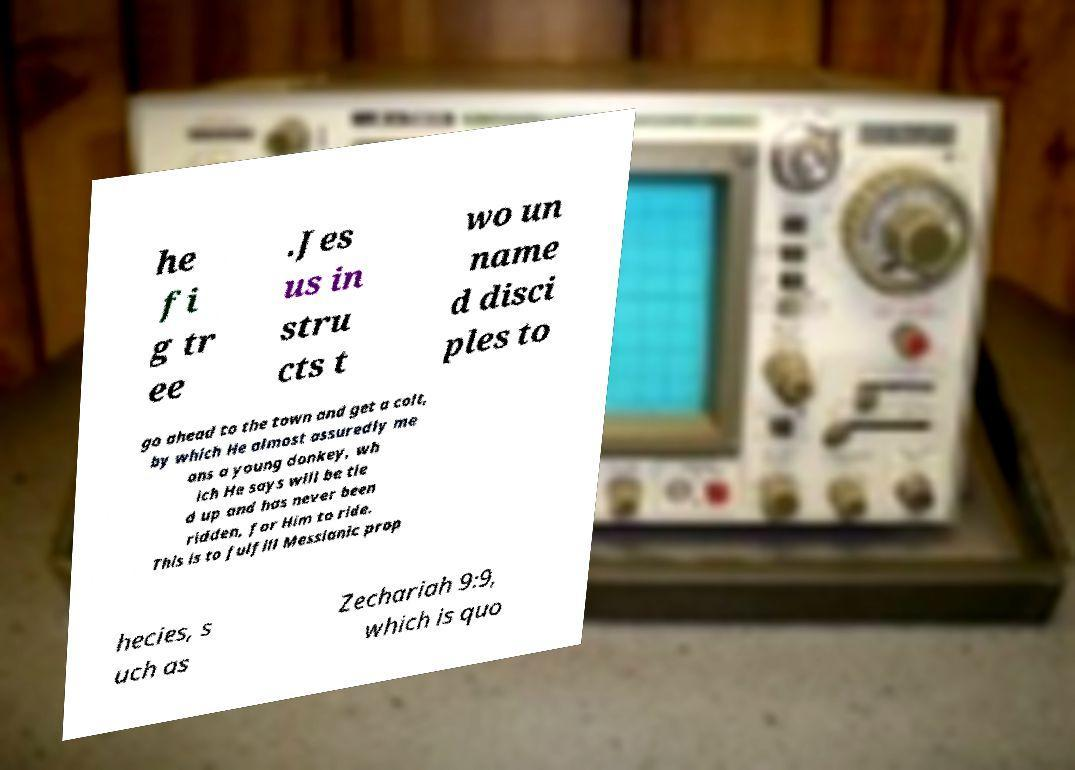Please read and relay the text visible in this image. What does it say? he fi g tr ee .Jes us in stru cts t wo un name d disci ples to go ahead to the town and get a colt, by which He almost assuredly me ans a young donkey, wh ich He says will be tie d up and has never been ridden, for Him to ride. This is to fulfill Messianic prop hecies, s uch as Zechariah 9:9, which is quo 